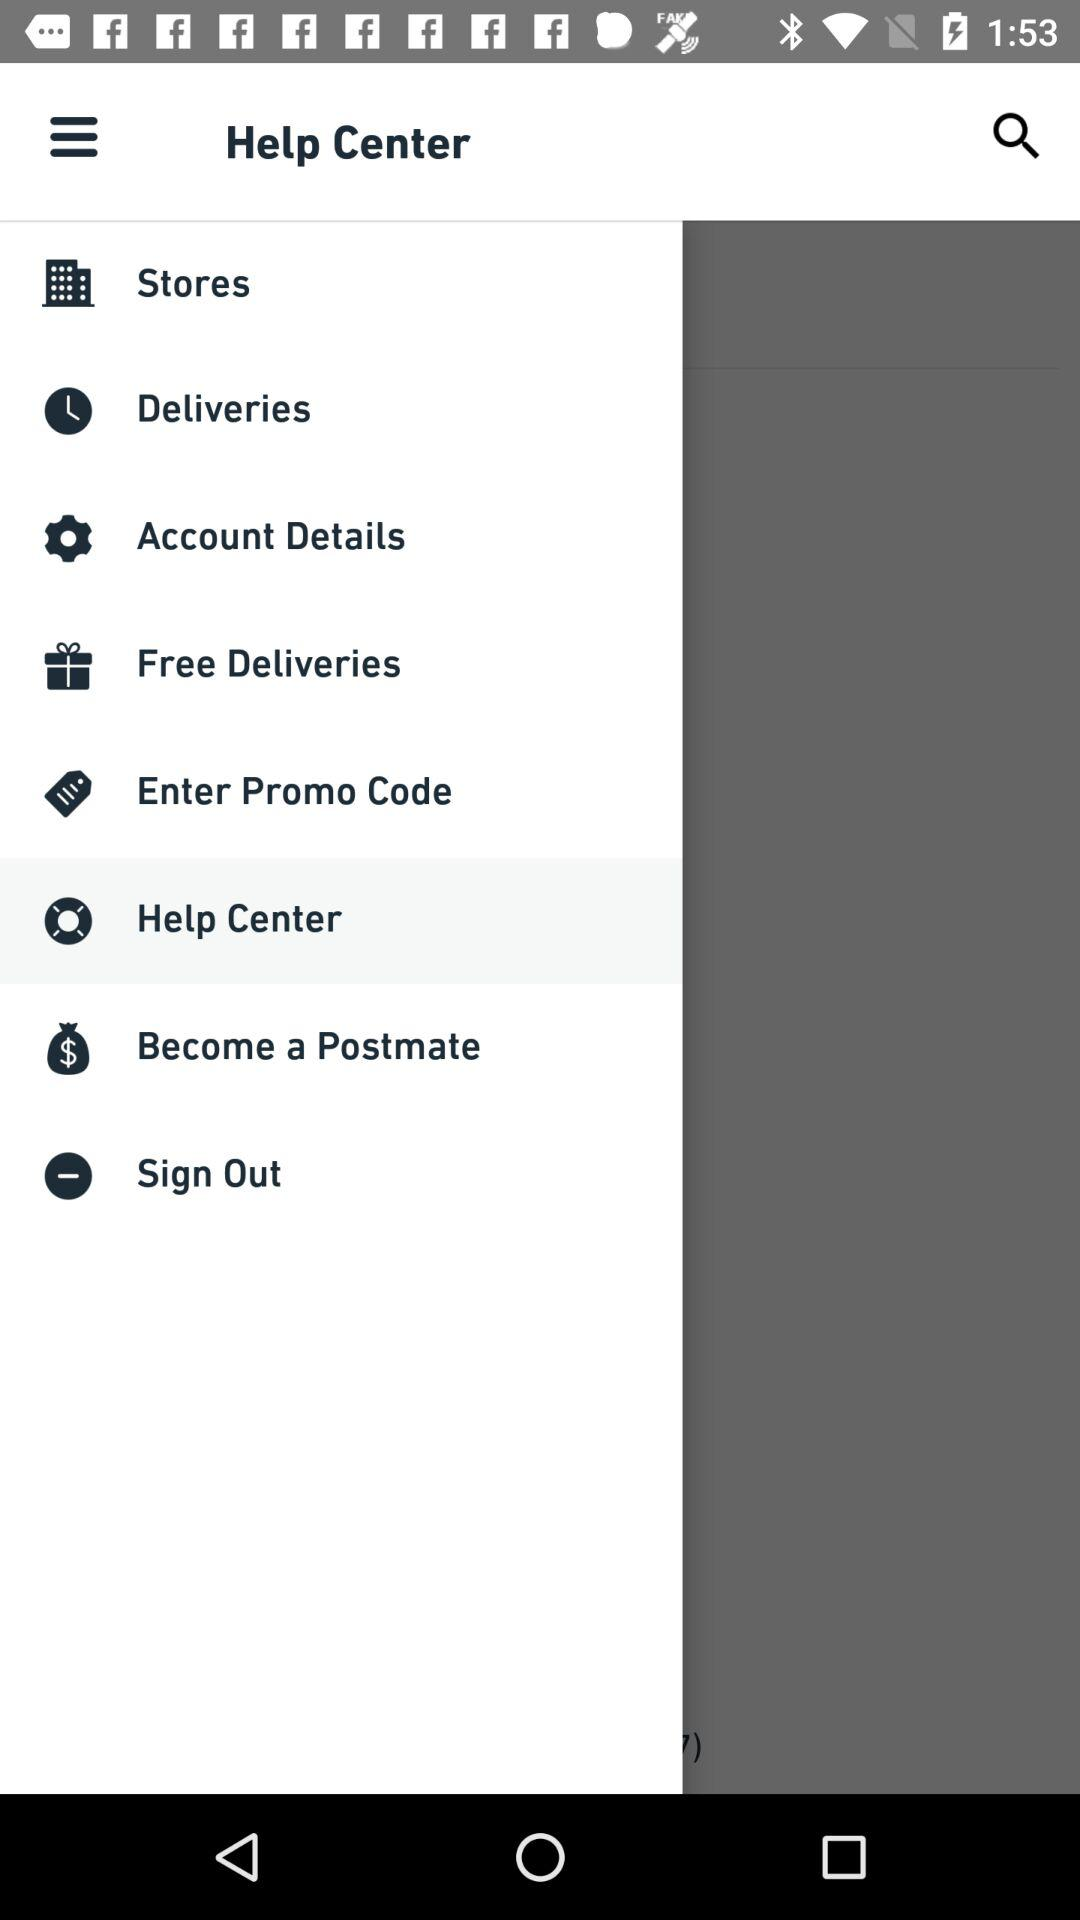Which option has been selected? The selected option is "Help Center". 